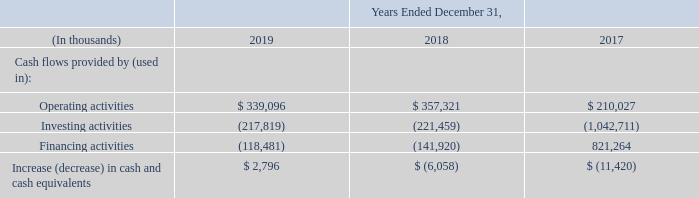Outlook and Overview Our operating requirements have historically been funded from cash flows generated from our business and borrowings under our credit facilities.
We expect that our future operating requirements will continue to be funded from cash flows from operating activities, existing cash and cash equivalents, and, if needed, from borrowings under our revolving credit facility and our ability to obtain future external financing.
We anticipate that we will continue to use a substantial portion of our cash flow to fund capital expenditures, meet scheduled payments of long-term debt, and to invest in future business opportunities.
The following table summarizes our cash flows:
How is the company planning to fund the future operating requirements? Cash flows from operating activities, existing cash and cash equivalents, and, if needed, from borrowings under our revolving credit facility and our ability to obtain future external financing. What was the cash flow from operating activities in 2019?
Answer scale should be: thousand. $ 339,096. What was the cash flow provided by investing activities in 2019?
Answer scale should be: thousand. (217,819). What was the increase / (decrease) in the cash flow from operating activities from 2018 to 2019?
Answer scale should be: thousand. 339,096 - 357,321
Answer: -18225. What was the average cash flow from investing activities for 2017-2019?
Answer scale should be: thousand. -(217,819 + 221,459 + 1,042,711) / 3
Answer: -493996.33. What was the percentage increase / (decrease) in the Increase (decrease) in cash and cash equivalents from 2018 to 2019?
Answer scale should be: percent. 2,796 / -6,058 - 1
Answer: -146.15. 